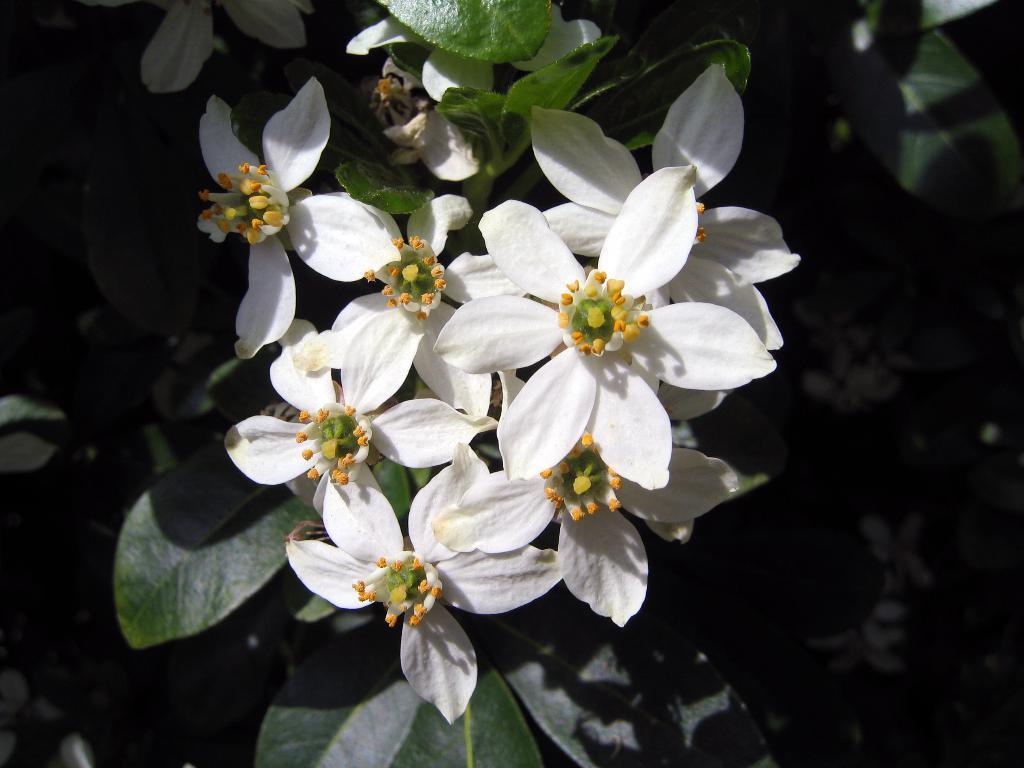How would you summarize this image in a sentence or two? In this image we can see some white flowers and the leaves. 